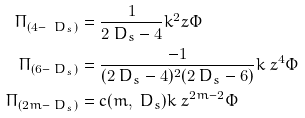<formula> <loc_0><loc_0><loc_500><loc_500>\Pi _ { ( 4 - \ D _ { s } ) } & = \frac { 1 } { 2 \ D _ { s } - 4 } k ^ { 2 } _ { \ } z \Phi \\ \Pi _ { ( 6 - \ D _ { s } ) } & = \frac { - 1 } { ( 2 \ D _ { s } - 4 ) ^ { 2 } ( 2 \ D _ { s } - 6 ) } k _ { \ } z ^ { 4 } \Phi \\ \Pi _ { ( 2 m - \ D _ { s } ) } & = c ( m , \ D _ { s } ) k _ { \ } z ^ { 2 m - 2 } \Phi</formula> 